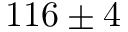<formula> <loc_0><loc_0><loc_500><loc_500>1 1 6 \pm 4</formula> 